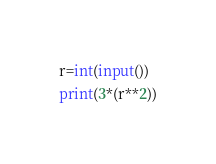Convert code to text. <code><loc_0><loc_0><loc_500><loc_500><_Python_>r=int(input())
print(3*(r**2))</code> 